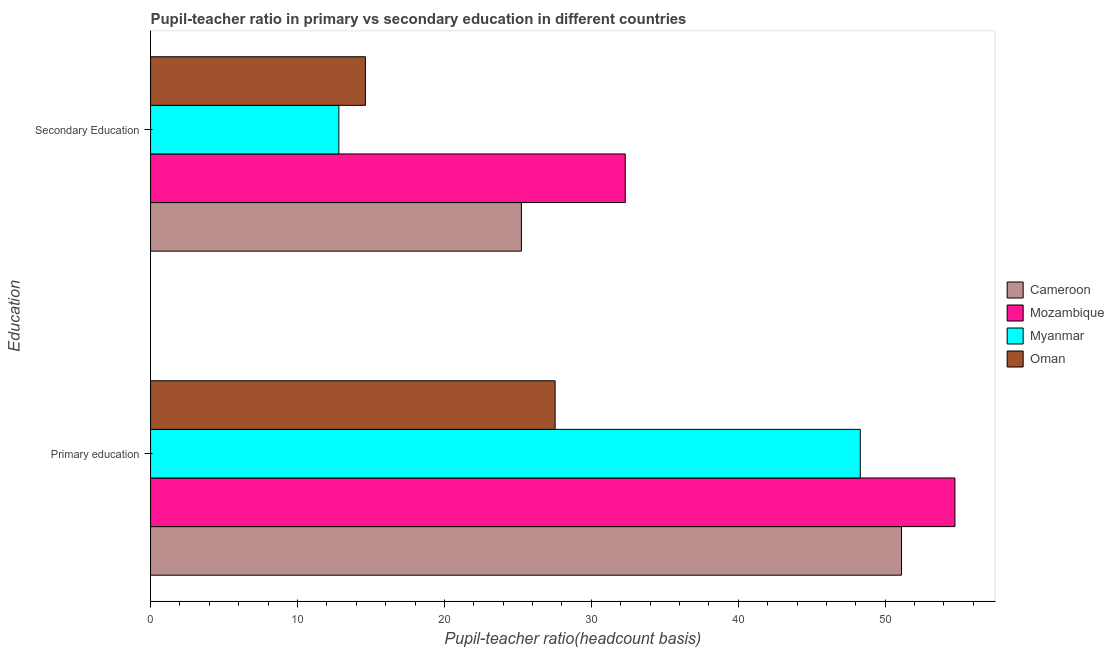How many different coloured bars are there?
Provide a short and direct response. 4. How many groups of bars are there?
Your response must be concise. 2. Are the number of bars per tick equal to the number of legend labels?
Offer a very short reply. Yes. Are the number of bars on each tick of the Y-axis equal?
Offer a terse response. Yes. How many bars are there on the 1st tick from the top?
Keep it short and to the point. 4. What is the label of the 1st group of bars from the top?
Provide a succinct answer. Secondary Education. What is the pupil-teacher ratio in primary education in Myanmar?
Ensure brevity in your answer.  48.3. Across all countries, what is the maximum pupil teacher ratio on secondary education?
Keep it short and to the point. 32.31. Across all countries, what is the minimum pupil teacher ratio on secondary education?
Your response must be concise. 12.82. In which country was the pupil teacher ratio on secondary education maximum?
Provide a short and direct response. Mozambique. In which country was the pupil teacher ratio on secondary education minimum?
Offer a terse response. Myanmar. What is the total pupil-teacher ratio in primary education in the graph?
Offer a very short reply. 181.7. What is the difference between the pupil-teacher ratio in primary education in Oman and that in Cameroon?
Give a very brief answer. -23.57. What is the difference between the pupil-teacher ratio in primary education in Oman and the pupil teacher ratio on secondary education in Cameroon?
Keep it short and to the point. 2.29. What is the average pupil-teacher ratio in primary education per country?
Your response must be concise. 45.42. What is the difference between the pupil-teacher ratio in primary education and pupil teacher ratio on secondary education in Oman?
Your answer should be very brief. 12.91. In how many countries, is the pupil-teacher ratio in primary education greater than 38 ?
Keep it short and to the point. 3. What is the ratio of the pupil teacher ratio on secondary education in Mozambique to that in Myanmar?
Ensure brevity in your answer.  2.52. What does the 4th bar from the top in Primary education represents?
Give a very brief answer. Cameroon. What does the 4th bar from the bottom in Secondary Education represents?
Provide a short and direct response. Oman. How many bars are there?
Your response must be concise. 8. Are all the bars in the graph horizontal?
Offer a terse response. Yes. How many countries are there in the graph?
Provide a succinct answer. 4. Are the values on the major ticks of X-axis written in scientific E-notation?
Give a very brief answer. No. How many legend labels are there?
Keep it short and to the point. 4. How are the legend labels stacked?
Make the answer very short. Vertical. What is the title of the graph?
Your response must be concise. Pupil-teacher ratio in primary vs secondary education in different countries. What is the label or title of the X-axis?
Your answer should be very brief. Pupil-teacher ratio(headcount basis). What is the label or title of the Y-axis?
Make the answer very short. Education. What is the Pupil-teacher ratio(headcount basis) in Cameroon in Primary education?
Offer a very short reply. 51.11. What is the Pupil-teacher ratio(headcount basis) in Mozambique in Primary education?
Your response must be concise. 54.75. What is the Pupil-teacher ratio(headcount basis) in Myanmar in Primary education?
Your answer should be compact. 48.3. What is the Pupil-teacher ratio(headcount basis) in Oman in Primary education?
Provide a short and direct response. 27.54. What is the Pupil-teacher ratio(headcount basis) of Cameroon in Secondary Education?
Provide a short and direct response. 25.24. What is the Pupil-teacher ratio(headcount basis) in Mozambique in Secondary Education?
Keep it short and to the point. 32.31. What is the Pupil-teacher ratio(headcount basis) in Myanmar in Secondary Education?
Offer a very short reply. 12.82. What is the Pupil-teacher ratio(headcount basis) in Oman in Secondary Education?
Your answer should be very brief. 14.62. Across all Education, what is the maximum Pupil-teacher ratio(headcount basis) of Cameroon?
Provide a short and direct response. 51.11. Across all Education, what is the maximum Pupil-teacher ratio(headcount basis) in Mozambique?
Your answer should be compact. 54.75. Across all Education, what is the maximum Pupil-teacher ratio(headcount basis) in Myanmar?
Your answer should be compact. 48.3. Across all Education, what is the maximum Pupil-teacher ratio(headcount basis) of Oman?
Give a very brief answer. 27.54. Across all Education, what is the minimum Pupil-teacher ratio(headcount basis) in Cameroon?
Your response must be concise. 25.24. Across all Education, what is the minimum Pupil-teacher ratio(headcount basis) in Mozambique?
Provide a short and direct response. 32.31. Across all Education, what is the minimum Pupil-teacher ratio(headcount basis) of Myanmar?
Provide a short and direct response. 12.82. Across all Education, what is the minimum Pupil-teacher ratio(headcount basis) of Oman?
Keep it short and to the point. 14.62. What is the total Pupil-teacher ratio(headcount basis) of Cameroon in the graph?
Keep it short and to the point. 76.35. What is the total Pupil-teacher ratio(headcount basis) of Mozambique in the graph?
Make the answer very short. 87.06. What is the total Pupil-teacher ratio(headcount basis) in Myanmar in the graph?
Give a very brief answer. 61.12. What is the total Pupil-teacher ratio(headcount basis) of Oman in the graph?
Keep it short and to the point. 42.16. What is the difference between the Pupil-teacher ratio(headcount basis) in Cameroon in Primary education and that in Secondary Education?
Give a very brief answer. 25.87. What is the difference between the Pupil-teacher ratio(headcount basis) of Mozambique in Primary education and that in Secondary Education?
Your answer should be compact. 22.44. What is the difference between the Pupil-teacher ratio(headcount basis) of Myanmar in Primary education and that in Secondary Education?
Offer a terse response. 35.49. What is the difference between the Pupil-teacher ratio(headcount basis) of Oman in Primary education and that in Secondary Education?
Your response must be concise. 12.91. What is the difference between the Pupil-teacher ratio(headcount basis) of Cameroon in Primary education and the Pupil-teacher ratio(headcount basis) of Mozambique in Secondary Education?
Your answer should be compact. 18.8. What is the difference between the Pupil-teacher ratio(headcount basis) in Cameroon in Primary education and the Pupil-teacher ratio(headcount basis) in Myanmar in Secondary Education?
Ensure brevity in your answer.  38.29. What is the difference between the Pupil-teacher ratio(headcount basis) in Cameroon in Primary education and the Pupil-teacher ratio(headcount basis) in Oman in Secondary Education?
Your answer should be very brief. 36.49. What is the difference between the Pupil-teacher ratio(headcount basis) of Mozambique in Primary education and the Pupil-teacher ratio(headcount basis) of Myanmar in Secondary Education?
Make the answer very short. 41.93. What is the difference between the Pupil-teacher ratio(headcount basis) of Mozambique in Primary education and the Pupil-teacher ratio(headcount basis) of Oman in Secondary Education?
Give a very brief answer. 40.13. What is the difference between the Pupil-teacher ratio(headcount basis) of Myanmar in Primary education and the Pupil-teacher ratio(headcount basis) of Oman in Secondary Education?
Your answer should be compact. 33.68. What is the average Pupil-teacher ratio(headcount basis) of Cameroon per Education?
Provide a short and direct response. 38.18. What is the average Pupil-teacher ratio(headcount basis) in Mozambique per Education?
Keep it short and to the point. 43.53. What is the average Pupil-teacher ratio(headcount basis) of Myanmar per Education?
Give a very brief answer. 30.56. What is the average Pupil-teacher ratio(headcount basis) in Oman per Education?
Provide a succinct answer. 21.08. What is the difference between the Pupil-teacher ratio(headcount basis) of Cameroon and Pupil-teacher ratio(headcount basis) of Mozambique in Primary education?
Offer a terse response. -3.64. What is the difference between the Pupil-teacher ratio(headcount basis) of Cameroon and Pupil-teacher ratio(headcount basis) of Myanmar in Primary education?
Offer a terse response. 2.8. What is the difference between the Pupil-teacher ratio(headcount basis) of Cameroon and Pupil-teacher ratio(headcount basis) of Oman in Primary education?
Your response must be concise. 23.57. What is the difference between the Pupil-teacher ratio(headcount basis) in Mozambique and Pupil-teacher ratio(headcount basis) in Myanmar in Primary education?
Your answer should be compact. 6.44. What is the difference between the Pupil-teacher ratio(headcount basis) of Mozambique and Pupil-teacher ratio(headcount basis) of Oman in Primary education?
Provide a short and direct response. 27.21. What is the difference between the Pupil-teacher ratio(headcount basis) of Myanmar and Pupil-teacher ratio(headcount basis) of Oman in Primary education?
Offer a very short reply. 20.77. What is the difference between the Pupil-teacher ratio(headcount basis) in Cameroon and Pupil-teacher ratio(headcount basis) in Mozambique in Secondary Education?
Your answer should be very brief. -7.07. What is the difference between the Pupil-teacher ratio(headcount basis) in Cameroon and Pupil-teacher ratio(headcount basis) in Myanmar in Secondary Education?
Offer a terse response. 12.42. What is the difference between the Pupil-teacher ratio(headcount basis) of Cameroon and Pupil-teacher ratio(headcount basis) of Oman in Secondary Education?
Your answer should be compact. 10.62. What is the difference between the Pupil-teacher ratio(headcount basis) in Mozambique and Pupil-teacher ratio(headcount basis) in Myanmar in Secondary Education?
Your response must be concise. 19.49. What is the difference between the Pupil-teacher ratio(headcount basis) of Mozambique and Pupil-teacher ratio(headcount basis) of Oman in Secondary Education?
Your answer should be compact. 17.69. What is the difference between the Pupil-teacher ratio(headcount basis) of Myanmar and Pupil-teacher ratio(headcount basis) of Oman in Secondary Education?
Offer a terse response. -1.81. What is the ratio of the Pupil-teacher ratio(headcount basis) of Cameroon in Primary education to that in Secondary Education?
Offer a terse response. 2.02. What is the ratio of the Pupil-teacher ratio(headcount basis) in Mozambique in Primary education to that in Secondary Education?
Your answer should be compact. 1.69. What is the ratio of the Pupil-teacher ratio(headcount basis) of Myanmar in Primary education to that in Secondary Education?
Provide a succinct answer. 3.77. What is the ratio of the Pupil-teacher ratio(headcount basis) in Oman in Primary education to that in Secondary Education?
Your response must be concise. 1.88. What is the difference between the highest and the second highest Pupil-teacher ratio(headcount basis) in Cameroon?
Give a very brief answer. 25.87. What is the difference between the highest and the second highest Pupil-teacher ratio(headcount basis) of Mozambique?
Ensure brevity in your answer.  22.44. What is the difference between the highest and the second highest Pupil-teacher ratio(headcount basis) in Myanmar?
Make the answer very short. 35.49. What is the difference between the highest and the second highest Pupil-teacher ratio(headcount basis) in Oman?
Keep it short and to the point. 12.91. What is the difference between the highest and the lowest Pupil-teacher ratio(headcount basis) in Cameroon?
Provide a short and direct response. 25.87. What is the difference between the highest and the lowest Pupil-teacher ratio(headcount basis) in Mozambique?
Keep it short and to the point. 22.44. What is the difference between the highest and the lowest Pupil-teacher ratio(headcount basis) of Myanmar?
Your answer should be compact. 35.49. What is the difference between the highest and the lowest Pupil-teacher ratio(headcount basis) of Oman?
Provide a succinct answer. 12.91. 